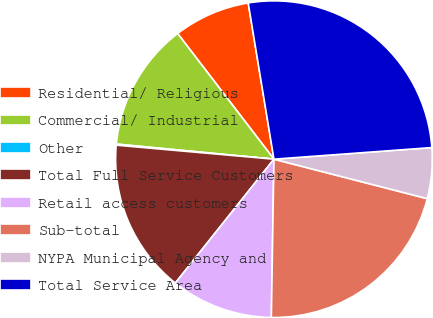Convert chart to OTSL. <chart><loc_0><loc_0><loc_500><loc_500><pie_chart><fcel>Residential/ Religious<fcel>Commercial/ Industrial<fcel>Other<fcel>Total Full Service Customers<fcel>Retail access customers<fcel>Sub-total<fcel>NYPA Municipal Agency and<fcel>Total Service Area<nl><fcel>7.81%<fcel>13.07%<fcel>0.11%<fcel>15.71%<fcel>10.44%<fcel>21.25%<fcel>5.18%<fcel>26.43%<nl></chart> 